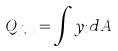<formula> <loc_0><loc_0><loc_500><loc_500>Q _ { j , x } = \int y _ { i } d A</formula> 